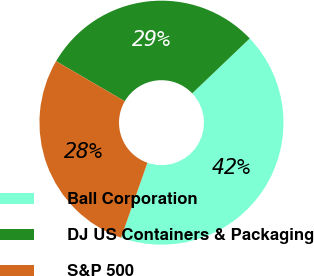<chart> <loc_0><loc_0><loc_500><loc_500><pie_chart><fcel>Ball Corporation<fcel>DJ US Containers & Packaging<fcel>S&P 500<nl><fcel>42.5%<fcel>29.47%<fcel>28.03%<nl></chart> 